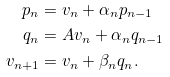<formula> <loc_0><loc_0><loc_500><loc_500>p _ { n } & = v _ { n } + \alpha _ { n } p _ { n - 1 } \\ q _ { n } & = A v _ { n } + \alpha _ { n } q _ { n - 1 } \\ v _ { n + 1 } & = v _ { n } + \beta _ { n } q _ { n } .</formula> 